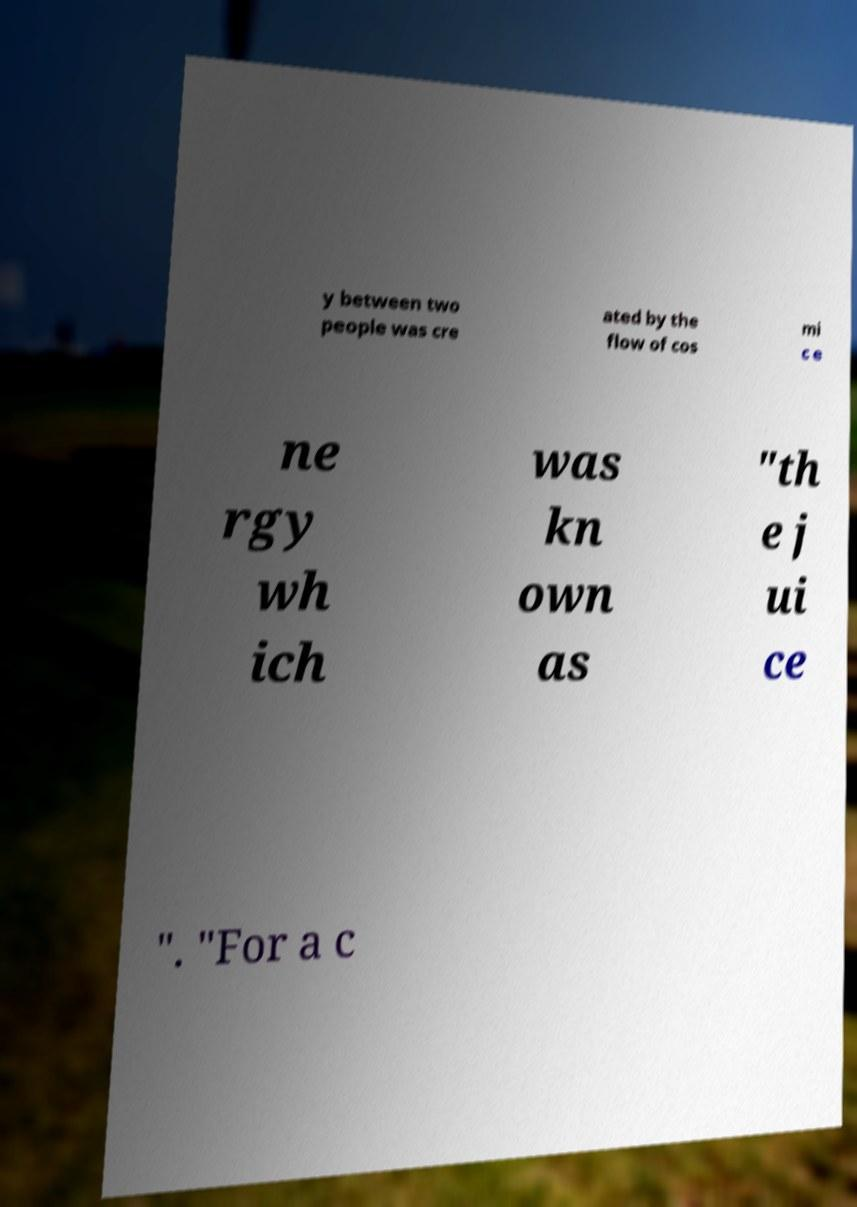I need the written content from this picture converted into text. Can you do that? y between two people was cre ated by the flow of cos mi c e ne rgy wh ich was kn own as "th e j ui ce ". "For a c 